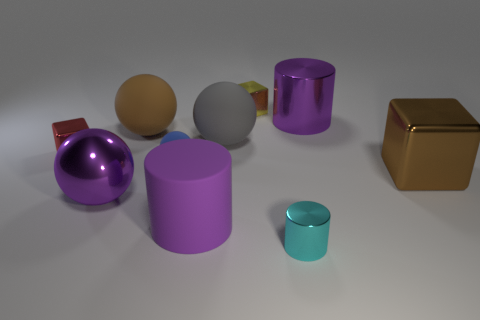Does the brown object left of the large purple rubber cylinder have the same size as the cyan shiny object that is in front of the small yellow object?
Offer a terse response. No. What is the material of the purple object that is the same shape as the brown matte object?
Provide a succinct answer. Metal. What is the color of the small cube that is in front of the purple cylinder that is right of the large purple cylinder on the left side of the cyan metal cylinder?
Make the answer very short. Red. Are there fewer large cylinders than cubes?
Your response must be concise. Yes. What is the color of the other shiny object that is the same shape as the cyan thing?
Ensure brevity in your answer.  Purple. What color is the cylinder that is the same material as the small ball?
Your answer should be very brief. Purple. How many purple cylinders are the same size as the brown rubber sphere?
Your answer should be very brief. 2. What is the material of the brown sphere?
Ensure brevity in your answer.  Rubber. Is the number of large purple metal cylinders greater than the number of big green balls?
Ensure brevity in your answer.  Yes. Does the big gray rubber object have the same shape as the yellow object?
Offer a terse response. No. 